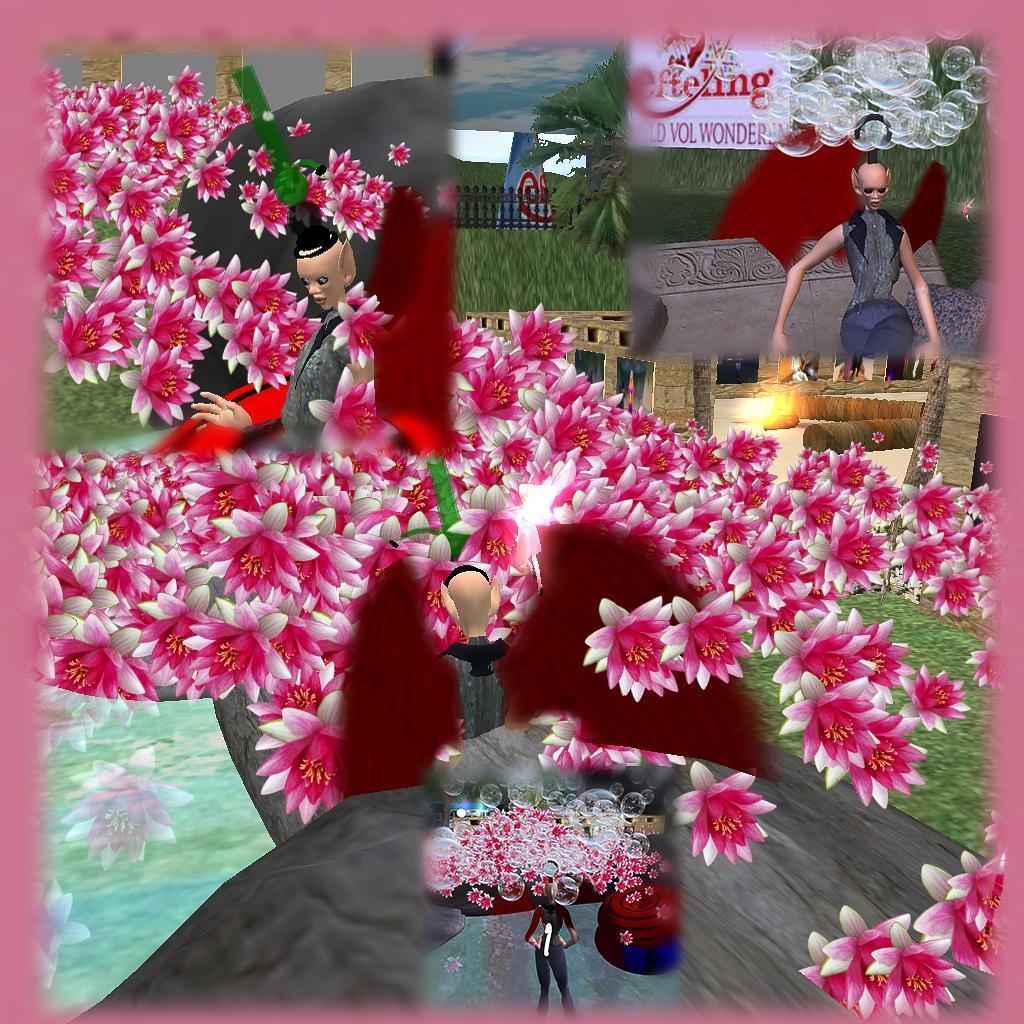Could you give a brief overview of what you see in this image? This is an animated image. In this picture, we see an object which looks like a table. Behind that, we see the flowers which are in white and pink color. Beside that, we see the person is standing. In the background, we see a person and in front of the person, we see a table on which some objects are placed. In the background, we see the railing and the board in white color with some text written. 